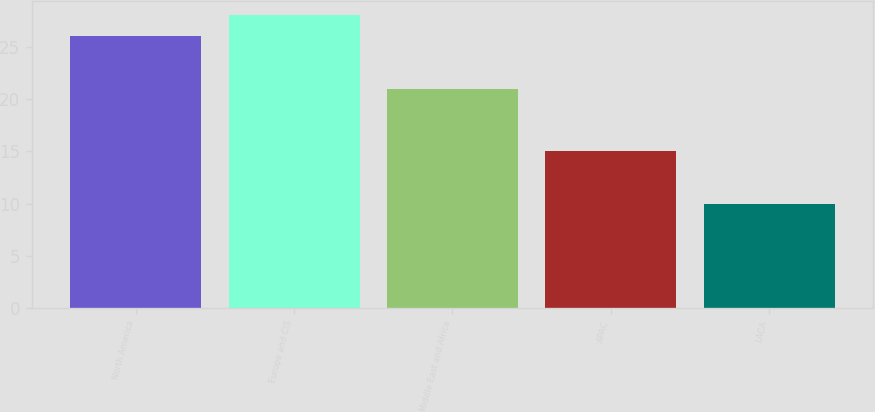Convert chart to OTSL. <chart><loc_0><loc_0><loc_500><loc_500><bar_chart><fcel>North America<fcel>Europe and CIS<fcel>Middle East and Africa<fcel>APAC<fcel>LACA<nl><fcel>26<fcel>28<fcel>21<fcel>15<fcel>10<nl></chart> 